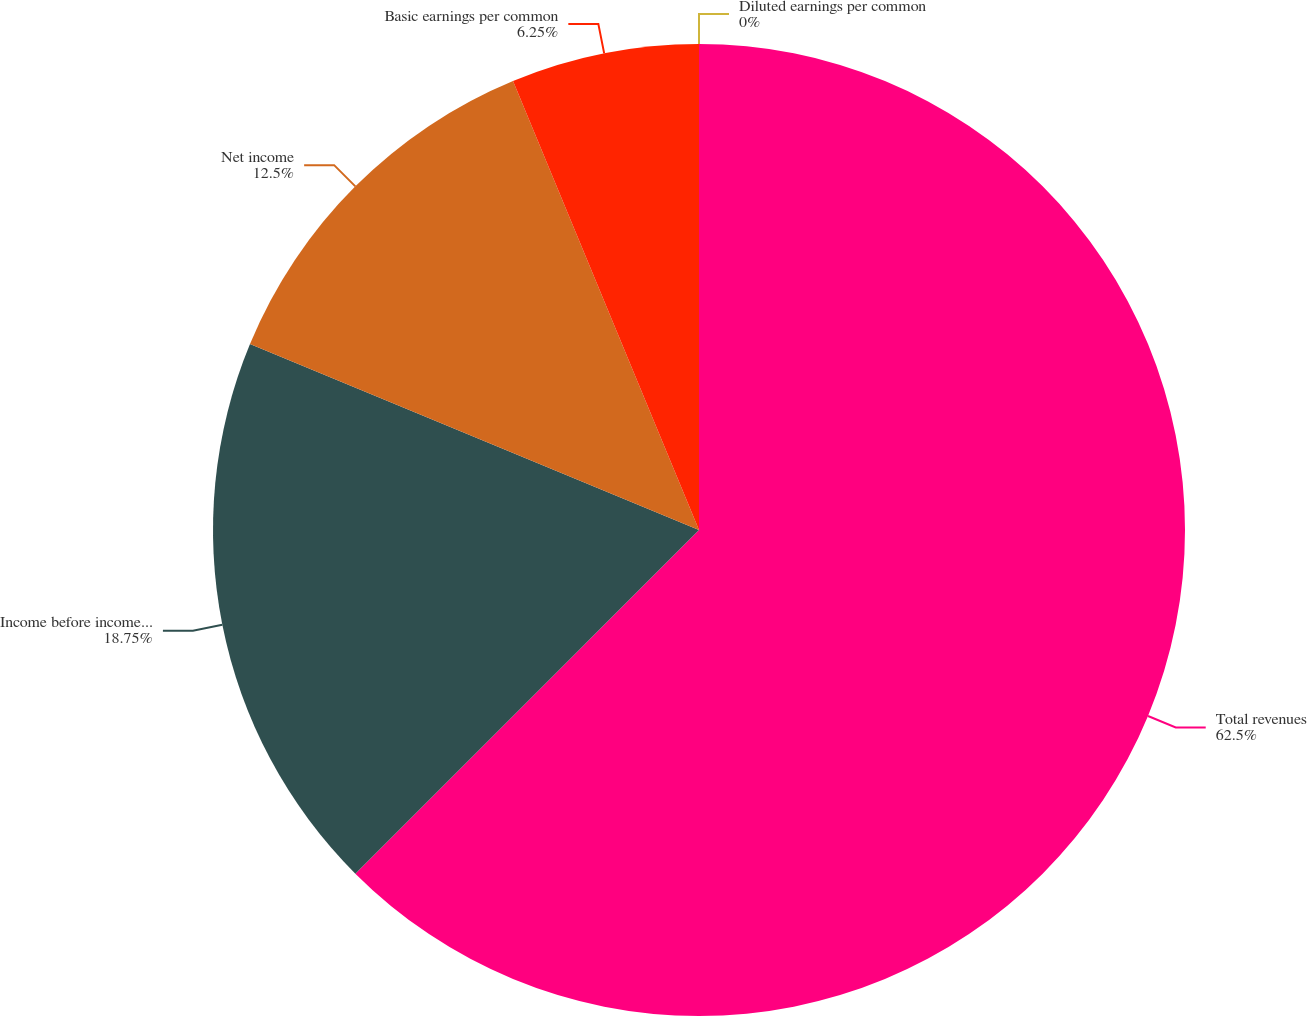<chart> <loc_0><loc_0><loc_500><loc_500><pie_chart><fcel>Total revenues<fcel>Income before income taxes<fcel>Net income<fcel>Basic earnings per common<fcel>Diluted earnings per common<nl><fcel>62.5%<fcel>18.75%<fcel>12.5%<fcel>6.25%<fcel>0.0%<nl></chart> 